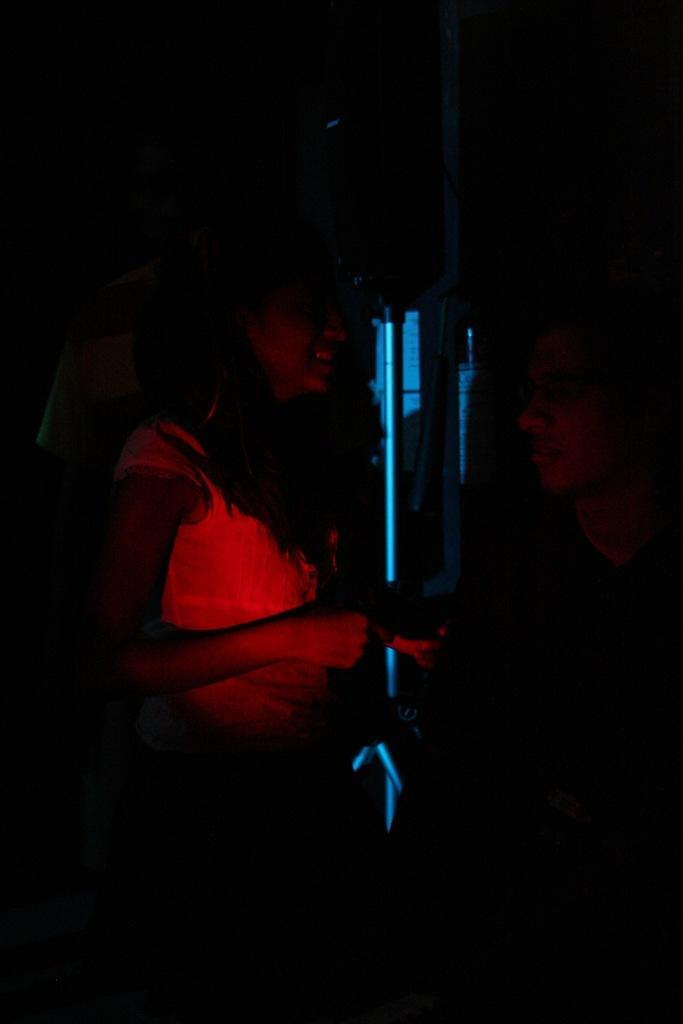What is the overall lighting condition of the image? The image is very dark. How many persons can be seen in the foreground of the image? There might be three persons in the foreground of the image. What is located in the middle of the image? There might be a stand visible in the middle of the image. What type of veil is draped over the stand in the image? There is no veil present in the image; the stand, if visible, is not shown with any drapery. 